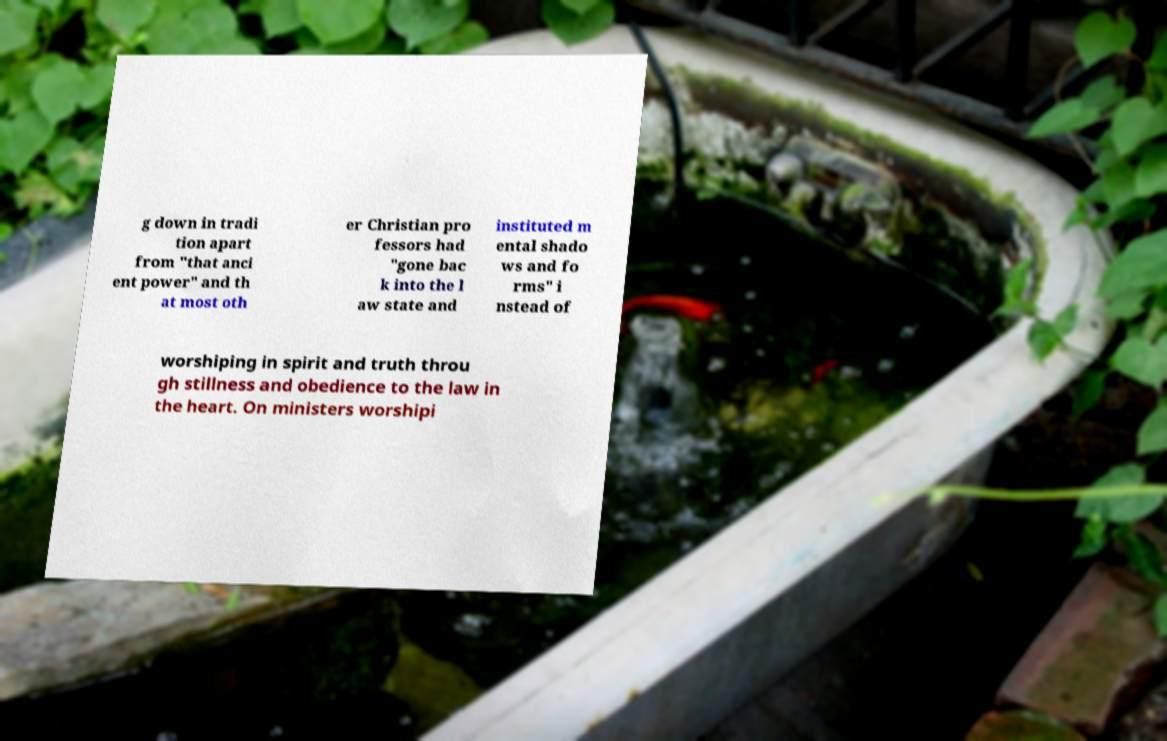There's text embedded in this image that I need extracted. Can you transcribe it verbatim? g down in tradi tion apart from "that anci ent power" and th at most oth er Christian pro fessors had "gone bac k into the l aw state and instituted m ental shado ws and fo rms" i nstead of worshiping in spirit and truth throu gh stillness and obedience to the law in the heart. On ministers worshipi 